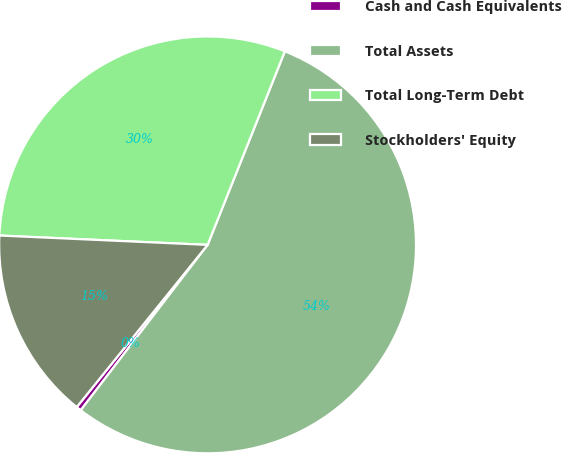Convert chart. <chart><loc_0><loc_0><loc_500><loc_500><pie_chart><fcel>Cash and Cash Equivalents<fcel>Total Assets<fcel>Total Long-Term Debt<fcel>Stockholders' Equity<nl><fcel>0.39%<fcel>54.37%<fcel>30.33%<fcel>14.91%<nl></chart> 